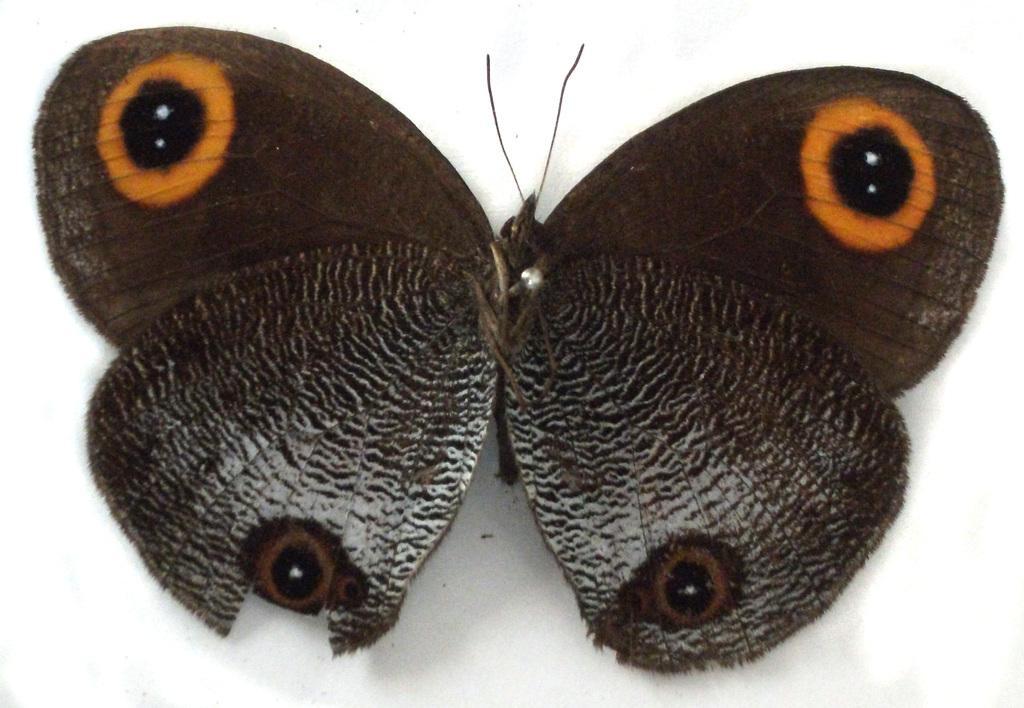Could you give a brief overview of what you see in this image? In the given image i can see a butterfly and in the background i can see the white surface. 